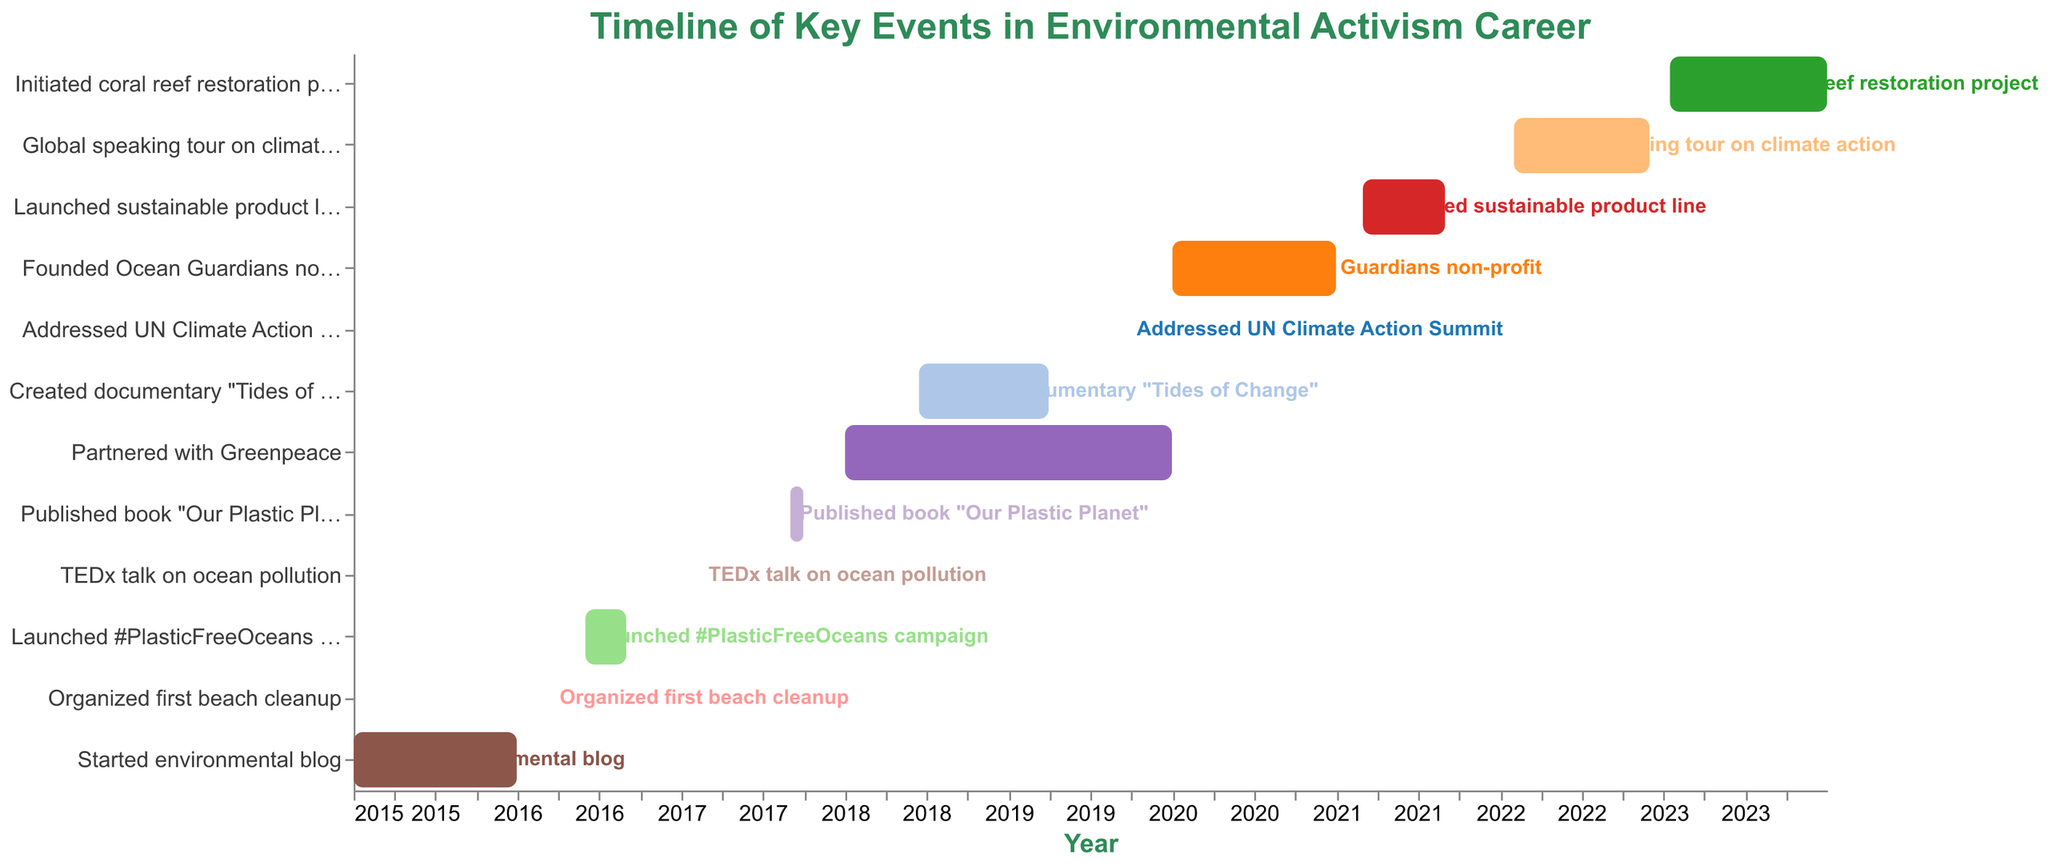What's the title of the chart? The title of the chart is prominently displayed at the top and reads "Timeline of Key Events in Environmental Activism Career."
Answer: Timeline of Key Events in Environmental Activism Career How many key events are listed in the influencer's environmental activism career? Count the number of distinct tasks listed on the vertical axis. There are 12 distinct key events.
Answer: 12 In which year did the influencer start their environmental blog? Refer to the horizontal axis and locate the label for "Started environmental blog," which begins in the year 2015.
Answer: 2015 Which event lasted the longest duration? Observe all the bars and measure their lengths by the difference between their start and end dates. The partnership with Greenpeace lasted from 2018 to 2019, making it the longest duration.
Answer: Partnered with Greenpeace Which event happened in 2019 for just one day? Find the task that has both its start and end dates within a single day in 2019. "Addressed UN Climate Action Summit" occurred on 2019-09-23.
Answer: Addressed UN Climate Action Summit What is the total duration in months for the "Global speaking tour on climate action"? The event starts on 2022-02-01 and ends on 2022-11-30. Calculate the duration as February through November, which is 10 months.
Answer: 10 months Name two events that spanned partially over the same period in 2018. Identify events where the timeframes overlap in 2018. "Partnered with Greenpeace" and "Created documentary 'Tides of Change'" both have activities in 2018.
Answer: Partnered with Greenpeace, Created documentary "Tides of Change" How long after launching the environmental blog did the influencer organize their first beach cleanup? "Started environmental blog" finished in December 2015 and "Organized first beach cleanup" happened in March 2016. The difference is three months.
Answer: 3 months Which event immediately follows the TEDx talk on ocean pollution? Locate "TEDx talk on ocean pollution" on the timeline, which occurred in February 2017. The next listed event is "Published book 'Our Plastic Planet'" in September 2017.
Answer: Published book "Our Plastic Planet" Compare the starting years of the "Launched sustainable product line" and the "Founded Ocean Guardians non-profit." Which came first? "Founded Ocean Guardians non-profit" began in 2020, and "Launched sustainable product line" began in 2021. The founding of the non-profit came first.
Answer: Founded Ocean Guardians non-profit 